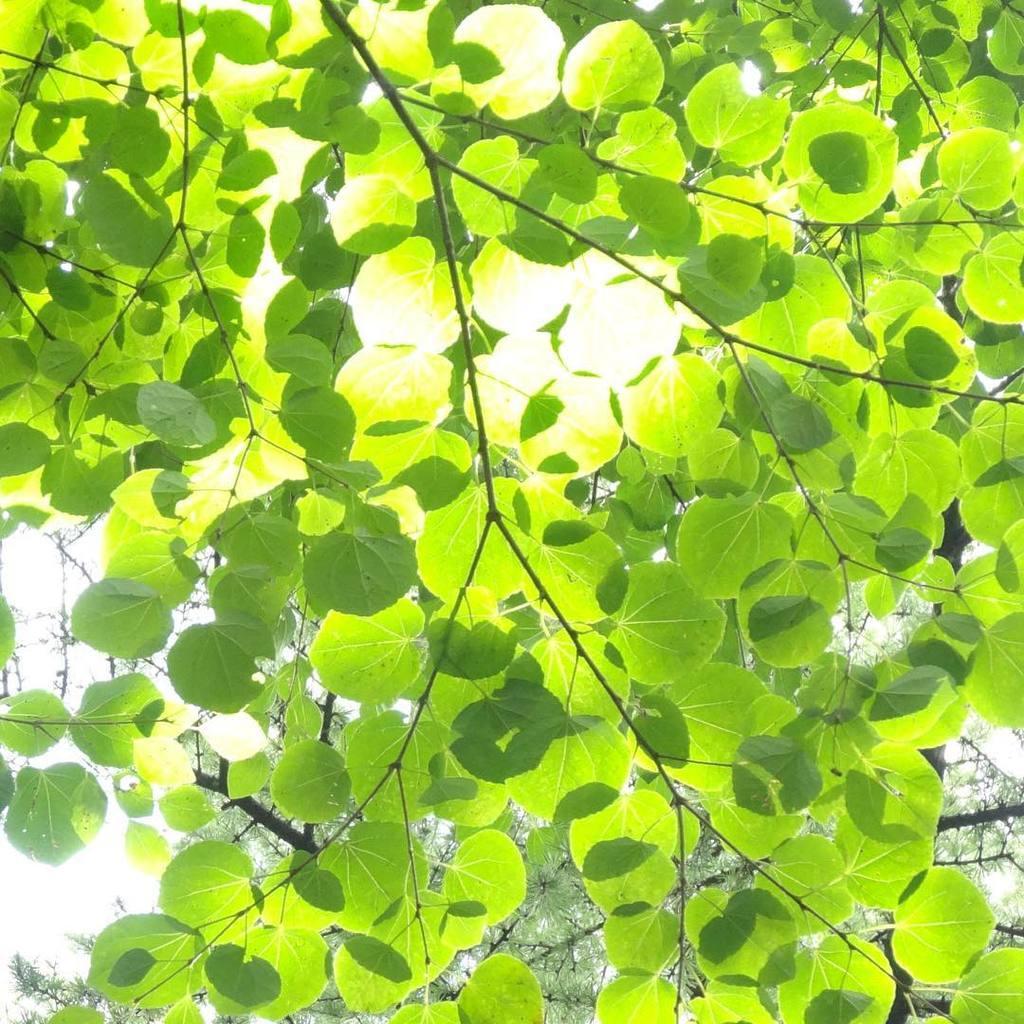Could you give a brief overview of what you see in this image? In this image, we can see trees and leaves. 